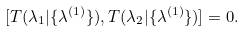<formula> <loc_0><loc_0><loc_500><loc_500>[ T ( \lambda _ { 1 } | \{ \lambda ^ { ( 1 ) } \} ) , T ( \lambda _ { 2 } | \{ \lambda ^ { ( 1 ) } \} ) ] = 0 .</formula> 